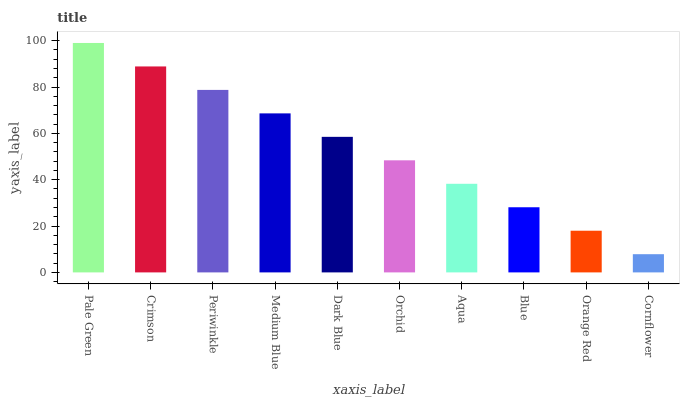Is Cornflower the minimum?
Answer yes or no. Yes. Is Pale Green the maximum?
Answer yes or no. Yes. Is Crimson the minimum?
Answer yes or no. No. Is Crimson the maximum?
Answer yes or no. No. Is Pale Green greater than Crimson?
Answer yes or no. Yes. Is Crimson less than Pale Green?
Answer yes or no. Yes. Is Crimson greater than Pale Green?
Answer yes or no. No. Is Pale Green less than Crimson?
Answer yes or no. No. Is Dark Blue the high median?
Answer yes or no. Yes. Is Orchid the low median?
Answer yes or no. Yes. Is Periwinkle the high median?
Answer yes or no. No. Is Cornflower the low median?
Answer yes or no. No. 